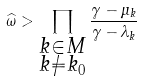Convert formula to latex. <formula><loc_0><loc_0><loc_500><loc_500>\widehat { \omega } > \prod _ { \substack { k \in M \\ k \ne k _ { 0 } } } \frac { \gamma - \mu _ { k } } { \gamma - \lambda _ { k } }</formula> 